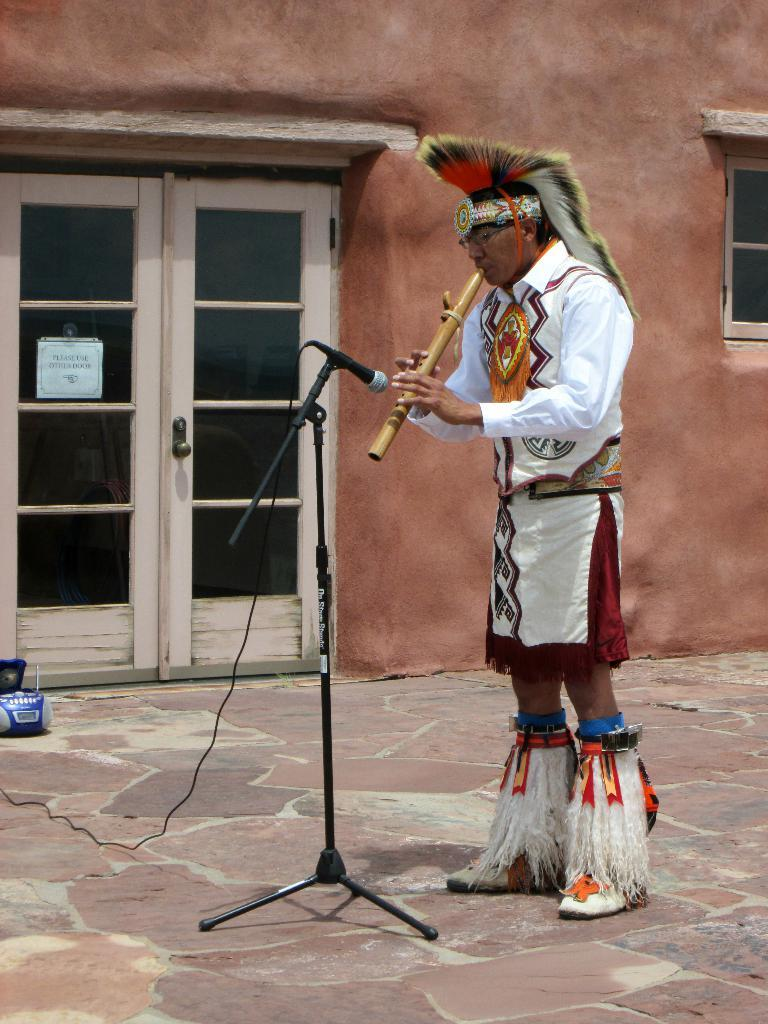What is the gender of the person in the image? There is a man in the image. What is the man in the image doing? The man is standing and playing a flute. How old is the boy playing the flute in the image? The image does not depict a boy; it features a man playing a flute. What type of duck can be seen swimming in the background of the image? There is no duck present in the image; it only features a man playing a flute. 